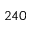Convert formula to latex. <formula><loc_0><loc_0><loc_500><loc_500>2 4 0</formula> 